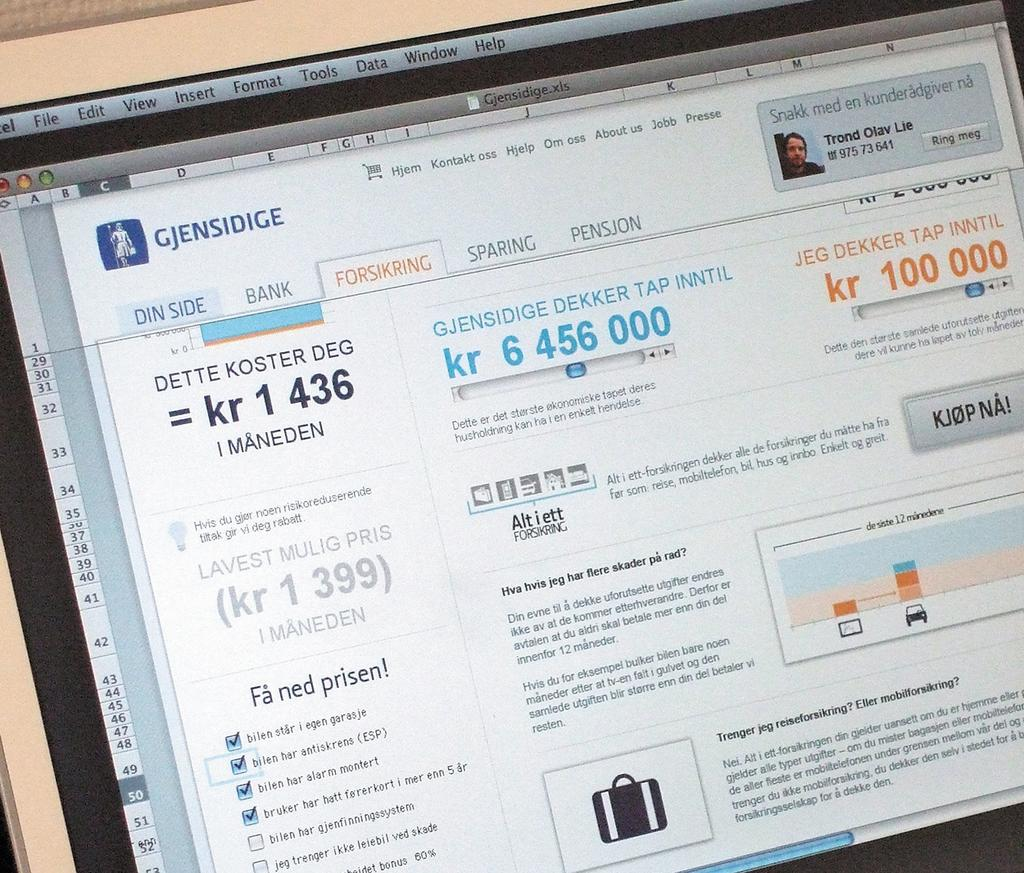<image>
Present a compact description of the photo's key features. a computer is showing a website of Gjensidige with a picture of a man on the right side. 